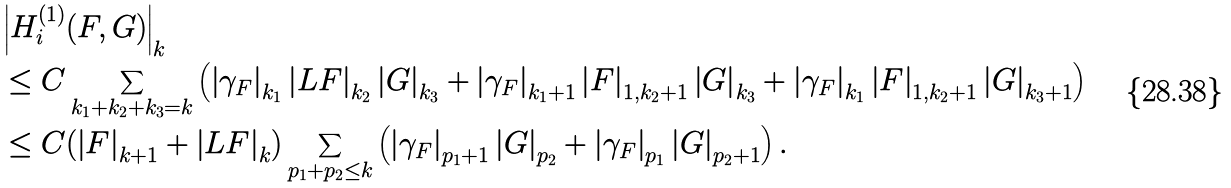Convert formula to latex. <formula><loc_0><loc_0><loc_500><loc_500>& \left | H _ { i } ^ { ( 1 ) } ( F , G ) \right | _ { k } \\ & \leq C \sum _ { k _ { 1 } + k _ { 2 } + k _ { 3 } = k } \left ( \left | \gamma _ { F } \right | _ { k _ { 1 } } \left | L F \right | _ { k _ { 2 } } \left | G \right | _ { k _ { 3 } } + \left | \gamma _ { F } \right | _ { k _ { 1 } + 1 } \left | F \right | _ { 1 , k _ { 2 } + 1 } \left | G \right | _ { k _ { 3 } } + \left | \gamma _ { F } \right | _ { k _ { 1 } } \left | F \right | _ { 1 , k _ { 2 } + 1 } \left | G \right | _ { k _ { 3 } + 1 } \right ) \\ & \leq C ( \left | F \right | _ { k + 1 } + \left | L F \right | _ { k } ) \sum _ { p _ { 1 } + p _ { 2 } \leq k } \left ( \left | \gamma _ { F } \right | _ { p _ { 1 } + 1 } \left | G \right | _ { p _ { 2 } } + \left | \gamma _ { F } \right | _ { p _ { 1 } } \left | G \right | _ { p _ { 2 } + 1 } \right ) .</formula> 